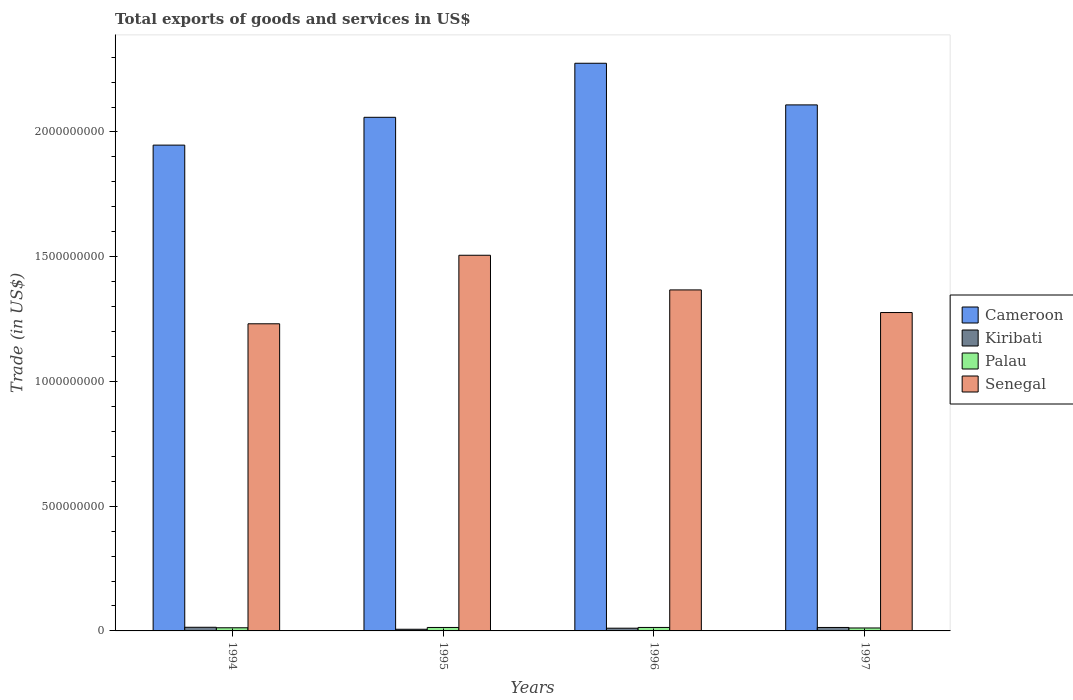How many bars are there on the 2nd tick from the left?
Give a very brief answer. 4. How many bars are there on the 4th tick from the right?
Ensure brevity in your answer.  4. What is the total exports of goods and services in Senegal in 1997?
Provide a short and direct response. 1.28e+09. Across all years, what is the maximum total exports of goods and services in Senegal?
Provide a short and direct response. 1.51e+09. Across all years, what is the minimum total exports of goods and services in Cameroon?
Provide a short and direct response. 1.95e+09. In which year was the total exports of goods and services in Kiribati maximum?
Provide a succinct answer. 1994. What is the total total exports of goods and services in Cameroon in the graph?
Ensure brevity in your answer.  8.39e+09. What is the difference between the total exports of goods and services in Kiribati in 1995 and that in 1996?
Keep it short and to the point. -4.28e+06. What is the difference between the total exports of goods and services in Cameroon in 1997 and the total exports of goods and services in Kiribati in 1995?
Give a very brief answer. 2.10e+09. What is the average total exports of goods and services in Senegal per year?
Offer a terse response. 1.35e+09. In the year 1997, what is the difference between the total exports of goods and services in Senegal and total exports of goods and services in Kiribati?
Ensure brevity in your answer.  1.26e+09. What is the ratio of the total exports of goods and services in Cameroon in 1994 to that in 1996?
Keep it short and to the point. 0.86. What is the difference between the highest and the second highest total exports of goods and services in Kiribati?
Offer a terse response. 7.67e+05. What is the difference between the highest and the lowest total exports of goods and services in Senegal?
Your response must be concise. 2.75e+08. In how many years, is the total exports of goods and services in Senegal greater than the average total exports of goods and services in Senegal taken over all years?
Offer a terse response. 2. What does the 2nd bar from the left in 1995 represents?
Your answer should be very brief. Kiribati. What does the 2nd bar from the right in 1995 represents?
Your response must be concise. Palau. Is it the case that in every year, the sum of the total exports of goods and services in Kiribati and total exports of goods and services in Senegal is greater than the total exports of goods and services in Palau?
Make the answer very short. Yes. How many years are there in the graph?
Provide a short and direct response. 4. What is the difference between two consecutive major ticks on the Y-axis?
Keep it short and to the point. 5.00e+08. Are the values on the major ticks of Y-axis written in scientific E-notation?
Your answer should be very brief. No. Does the graph contain any zero values?
Give a very brief answer. No. Does the graph contain grids?
Your answer should be very brief. No. Where does the legend appear in the graph?
Offer a very short reply. Center right. What is the title of the graph?
Your answer should be very brief. Total exports of goods and services in US$. What is the label or title of the Y-axis?
Offer a very short reply. Trade (in US$). What is the Trade (in US$) of Cameroon in 1994?
Offer a terse response. 1.95e+09. What is the Trade (in US$) of Kiribati in 1994?
Give a very brief answer. 1.46e+07. What is the Trade (in US$) of Palau in 1994?
Your response must be concise. 1.26e+07. What is the Trade (in US$) of Senegal in 1994?
Your answer should be compact. 1.23e+09. What is the Trade (in US$) of Cameroon in 1995?
Ensure brevity in your answer.  2.06e+09. What is the Trade (in US$) of Kiribati in 1995?
Provide a succinct answer. 6.67e+06. What is the Trade (in US$) of Palau in 1995?
Provide a short and direct response. 1.39e+07. What is the Trade (in US$) in Senegal in 1995?
Ensure brevity in your answer.  1.51e+09. What is the Trade (in US$) in Cameroon in 1996?
Offer a terse response. 2.28e+09. What is the Trade (in US$) of Kiribati in 1996?
Offer a very short reply. 1.10e+07. What is the Trade (in US$) of Palau in 1996?
Your answer should be very brief. 1.39e+07. What is the Trade (in US$) of Senegal in 1996?
Your response must be concise. 1.37e+09. What is the Trade (in US$) of Cameroon in 1997?
Offer a terse response. 2.11e+09. What is the Trade (in US$) in Kiribati in 1997?
Offer a very short reply. 1.39e+07. What is the Trade (in US$) in Palau in 1997?
Your answer should be compact. 1.18e+07. What is the Trade (in US$) in Senegal in 1997?
Keep it short and to the point. 1.28e+09. Across all years, what is the maximum Trade (in US$) of Cameroon?
Make the answer very short. 2.28e+09. Across all years, what is the maximum Trade (in US$) in Kiribati?
Your response must be concise. 1.46e+07. Across all years, what is the maximum Trade (in US$) in Palau?
Give a very brief answer. 1.39e+07. Across all years, what is the maximum Trade (in US$) of Senegal?
Your response must be concise. 1.51e+09. Across all years, what is the minimum Trade (in US$) in Cameroon?
Provide a short and direct response. 1.95e+09. Across all years, what is the minimum Trade (in US$) of Kiribati?
Your answer should be very brief. 6.67e+06. Across all years, what is the minimum Trade (in US$) in Palau?
Your response must be concise. 1.18e+07. Across all years, what is the minimum Trade (in US$) of Senegal?
Give a very brief answer. 1.23e+09. What is the total Trade (in US$) in Cameroon in the graph?
Offer a terse response. 8.39e+09. What is the total Trade (in US$) in Kiribati in the graph?
Your answer should be compact. 4.62e+07. What is the total Trade (in US$) of Palau in the graph?
Offer a terse response. 5.22e+07. What is the total Trade (in US$) in Senegal in the graph?
Offer a terse response. 5.38e+09. What is the difference between the Trade (in US$) in Cameroon in 1994 and that in 1995?
Your answer should be very brief. -1.11e+08. What is the difference between the Trade (in US$) of Kiribati in 1994 and that in 1995?
Provide a succinct answer. 7.97e+06. What is the difference between the Trade (in US$) of Palau in 1994 and that in 1995?
Offer a very short reply. -1.27e+06. What is the difference between the Trade (in US$) in Senegal in 1994 and that in 1995?
Your answer should be very brief. -2.75e+08. What is the difference between the Trade (in US$) in Cameroon in 1994 and that in 1996?
Provide a succinct answer. -3.28e+08. What is the difference between the Trade (in US$) in Kiribati in 1994 and that in 1996?
Your answer should be very brief. 3.69e+06. What is the difference between the Trade (in US$) in Palau in 1994 and that in 1996?
Provide a succinct answer. -1.31e+06. What is the difference between the Trade (in US$) in Senegal in 1994 and that in 1996?
Your response must be concise. -1.36e+08. What is the difference between the Trade (in US$) of Cameroon in 1994 and that in 1997?
Ensure brevity in your answer.  -1.61e+08. What is the difference between the Trade (in US$) of Kiribati in 1994 and that in 1997?
Provide a succinct answer. 7.67e+05. What is the difference between the Trade (in US$) of Palau in 1994 and that in 1997?
Offer a terse response. 7.88e+05. What is the difference between the Trade (in US$) in Senegal in 1994 and that in 1997?
Offer a terse response. -4.51e+07. What is the difference between the Trade (in US$) of Cameroon in 1995 and that in 1996?
Make the answer very short. -2.17e+08. What is the difference between the Trade (in US$) of Kiribati in 1995 and that in 1996?
Give a very brief answer. -4.28e+06. What is the difference between the Trade (in US$) of Palau in 1995 and that in 1996?
Your answer should be compact. -3.90e+04. What is the difference between the Trade (in US$) of Senegal in 1995 and that in 1996?
Make the answer very short. 1.39e+08. What is the difference between the Trade (in US$) in Cameroon in 1995 and that in 1997?
Make the answer very short. -4.98e+07. What is the difference between the Trade (in US$) in Kiribati in 1995 and that in 1997?
Your answer should be very brief. -7.21e+06. What is the difference between the Trade (in US$) of Palau in 1995 and that in 1997?
Provide a succinct answer. 2.06e+06. What is the difference between the Trade (in US$) in Senegal in 1995 and that in 1997?
Provide a short and direct response. 2.30e+08. What is the difference between the Trade (in US$) of Cameroon in 1996 and that in 1997?
Offer a very short reply. 1.67e+08. What is the difference between the Trade (in US$) of Kiribati in 1996 and that in 1997?
Keep it short and to the point. -2.92e+06. What is the difference between the Trade (in US$) in Palau in 1996 and that in 1997?
Offer a terse response. 2.10e+06. What is the difference between the Trade (in US$) in Senegal in 1996 and that in 1997?
Provide a short and direct response. 9.07e+07. What is the difference between the Trade (in US$) in Cameroon in 1994 and the Trade (in US$) in Kiribati in 1995?
Ensure brevity in your answer.  1.94e+09. What is the difference between the Trade (in US$) in Cameroon in 1994 and the Trade (in US$) in Palau in 1995?
Your response must be concise. 1.93e+09. What is the difference between the Trade (in US$) in Cameroon in 1994 and the Trade (in US$) in Senegal in 1995?
Your answer should be compact. 4.42e+08. What is the difference between the Trade (in US$) of Kiribati in 1994 and the Trade (in US$) of Palau in 1995?
Provide a succinct answer. 7.78e+05. What is the difference between the Trade (in US$) in Kiribati in 1994 and the Trade (in US$) in Senegal in 1995?
Keep it short and to the point. -1.49e+09. What is the difference between the Trade (in US$) of Palau in 1994 and the Trade (in US$) of Senegal in 1995?
Provide a short and direct response. -1.49e+09. What is the difference between the Trade (in US$) in Cameroon in 1994 and the Trade (in US$) in Kiribati in 1996?
Provide a short and direct response. 1.94e+09. What is the difference between the Trade (in US$) in Cameroon in 1994 and the Trade (in US$) in Palau in 1996?
Offer a very short reply. 1.93e+09. What is the difference between the Trade (in US$) of Cameroon in 1994 and the Trade (in US$) of Senegal in 1996?
Your answer should be compact. 5.80e+08. What is the difference between the Trade (in US$) in Kiribati in 1994 and the Trade (in US$) in Palau in 1996?
Ensure brevity in your answer.  7.39e+05. What is the difference between the Trade (in US$) in Kiribati in 1994 and the Trade (in US$) in Senegal in 1996?
Your answer should be very brief. -1.35e+09. What is the difference between the Trade (in US$) of Palau in 1994 and the Trade (in US$) of Senegal in 1996?
Offer a very short reply. -1.35e+09. What is the difference between the Trade (in US$) in Cameroon in 1994 and the Trade (in US$) in Kiribati in 1997?
Give a very brief answer. 1.93e+09. What is the difference between the Trade (in US$) in Cameroon in 1994 and the Trade (in US$) in Palau in 1997?
Your answer should be very brief. 1.94e+09. What is the difference between the Trade (in US$) of Cameroon in 1994 and the Trade (in US$) of Senegal in 1997?
Ensure brevity in your answer.  6.71e+08. What is the difference between the Trade (in US$) of Kiribati in 1994 and the Trade (in US$) of Palau in 1997?
Provide a succinct answer. 2.83e+06. What is the difference between the Trade (in US$) in Kiribati in 1994 and the Trade (in US$) in Senegal in 1997?
Your answer should be compact. -1.26e+09. What is the difference between the Trade (in US$) of Palau in 1994 and the Trade (in US$) of Senegal in 1997?
Provide a short and direct response. -1.26e+09. What is the difference between the Trade (in US$) in Cameroon in 1995 and the Trade (in US$) in Kiribati in 1996?
Give a very brief answer. 2.05e+09. What is the difference between the Trade (in US$) in Cameroon in 1995 and the Trade (in US$) in Palau in 1996?
Your answer should be very brief. 2.04e+09. What is the difference between the Trade (in US$) of Cameroon in 1995 and the Trade (in US$) of Senegal in 1996?
Provide a succinct answer. 6.92e+08. What is the difference between the Trade (in US$) in Kiribati in 1995 and the Trade (in US$) in Palau in 1996?
Offer a terse response. -7.24e+06. What is the difference between the Trade (in US$) of Kiribati in 1995 and the Trade (in US$) of Senegal in 1996?
Provide a succinct answer. -1.36e+09. What is the difference between the Trade (in US$) of Palau in 1995 and the Trade (in US$) of Senegal in 1996?
Your answer should be compact. -1.35e+09. What is the difference between the Trade (in US$) of Cameroon in 1995 and the Trade (in US$) of Kiribati in 1997?
Your answer should be very brief. 2.05e+09. What is the difference between the Trade (in US$) in Cameroon in 1995 and the Trade (in US$) in Palau in 1997?
Ensure brevity in your answer.  2.05e+09. What is the difference between the Trade (in US$) of Cameroon in 1995 and the Trade (in US$) of Senegal in 1997?
Offer a very short reply. 7.83e+08. What is the difference between the Trade (in US$) of Kiribati in 1995 and the Trade (in US$) of Palau in 1997?
Make the answer very short. -5.14e+06. What is the difference between the Trade (in US$) of Kiribati in 1995 and the Trade (in US$) of Senegal in 1997?
Your response must be concise. -1.27e+09. What is the difference between the Trade (in US$) of Palau in 1995 and the Trade (in US$) of Senegal in 1997?
Make the answer very short. -1.26e+09. What is the difference between the Trade (in US$) in Cameroon in 1996 and the Trade (in US$) in Kiribati in 1997?
Make the answer very short. 2.26e+09. What is the difference between the Trade (in US$) of Cameroon in 1996 and the Trade (in US$) of Palau in 1997?
Keep it short and to the point. 2.26e+09. What is the difference between the Trade (in US$) in Cameroon in 1996 and the Trade (in US$) in Senegal in 1997?
Give a very brief answer. 9.99e+08. What is the difference between the Trade (in US$) in Kiribati in 1996 and the Trade (in US$) in Palau in 1997?
Ensure brevity in your answer.  -8.57e+05. What is the difference between the Trade (in US$) in Kiribati in 1996 and the Trade (in US$) in Senegal in 1997?
Offer a terse response. -1.27e+09. What is the difference between the Trade (in US$) of Palau in 1996 and the Trade (in US$) of Senegal in 1997?
Make the answer very short. -1.26e+09. What is the average Trade (in US$) of Cameroon per year?
Offer a very short reply. 2.10e+09. What is the average Trade (in US$) in Kiribati per year?
Offer a terse response. 1.15e+07. What is the average Trade (in US$) of Palau per year?
Offer a terse response. 1.30e+07. What is the average Trade (in US$) in Senegal per year?
Your response must be concise. 1.35e+09. In the year 1994, what is the difference between the Trade (in US$) of Cameroon and Trade (in US$) of Kiribati?
Your answer should be very brief. 1.93e+09. In the year 1994, what is the difference between the Trade (in US$) of Cameroon and Trade (in US$) of Palau?
Make the answer very short. 1.93e+09. In the year 1994, what is the difference between the Trade (in US$) of Cameroon and Trade (in US$) of Senegal?
Ensure brevity in your answer.  7.16e+08. In the year 1994, what is the difference between the Trade (in US$) of Kiribati and Trade (in US$) of Palau?
Ensure brevity in your answer.  2.05e+06. In the year 1994, what is the difference between the Trade (in US$) in Kiribati and Trade (in US$) in Senegal?
Your answer should be very brief. -1.22e+09. In the year 1994, what is the difference between the Trade (in US$) in Palau and Trade (in US$) in Senegal?
Offer a terse response. -1.22e+09. In the year 1995, what is the difference between the Trade (in US$) in Cameroon and Trade (in US$) in Kiribati?
Ensure brevity in your answer.  2.05e+09. In the year 1995, what is the difference between the Trade (in US$) in Cameroon and Trade (in US$) in Palau?
Offer a very short reply. 2.05e+09. In the year 1995, what is the difference between the Trade (in US$) in Cameroon and Trade (in US$) in Senegal?
Ensure brevity in your answer.  5.53e+08. In the year 1995, what is the difference between the Trade (in US$) in Kiribati and Trade (in US$) in Palau?
Offer a very short reply. -7.20e+06. In the year 1995, what is the difference between the Trade (in US$) of Kiribati and Trade (in US$) of Senegal?
Ensure brevity in your answer.  -1.50e+09. In the year 1995, what is the difference between the Trade (in US$) of Palau and Trade (in US$) of Senegal?
Provide a succinct answer. -1.49e+09. In the year 1996, what is the difference between the Trade (in US$) of Cameroon and Trade (in US$) of Kiribati?
Provide a succinct answer. 2.26e+09. In the year 1996, what is the difference between the Trade (in US$) of Cameroon and Trade (in US$) of Palau?
Your answer should be compact. 2.26e+09. In the year 1996, what is the difference between the Trade (in US$) of Cameroon and Trade (in US$) of Senegal?
Give a very brief answer. 9.09e+08. In the year 1996, what is the difference between the Trade (in US$) of Kiribati and Trade (in US$) of Palau?
Your answer should be very brief. -2.95e+06. In the year 1996, what is the difference between the Trade (in US$) of Kiribati and Trade (in US$) of Senegal?
Offer a terse response. -1.36e+09. In the year 1996, what is the difference between the Trade (in US$) in Palau and Trade (in US$) in Senegal?
Your answer should be compact. -1.35e+09. In the year 1997, what is the difference between the Trade (in US$) of Cameroon and Trade (in US$) of Kiribati?
Make the answer very short. 2.09e+09. In the year 1997, what is the difference between the Trade (in US$) in Cameroon and Trade (in US$) in Palau?
Offer a very short reply. 2.10e+09. In the year 1997, what is the difference between the Trade (in US$) of Cameroon and Trade (in US$) of Senegal?
Your answer should be compact. 8.32e+08. In the year 1997, what is the difference between the Trade (in US$) of Kiribati and Trade (in US$) of Palau?
Give a very brief answer. 2.07e+06. In the year 1997, what is the difference between the Trade (in US$) in Kiribati and Trade (in US$) in Senegal?
Your answer should be very brief. -1.26e+09. In the year 1997, what is the difference between the Trade (in US$) in Palau and Trade (in US$) in Senegal?
Your answer should be very brief. -1.26e+09. What is the ratio of the Trade (in US$) of Cameroon in 1994 to that in 1995?
Provide a short and direct response. 0.95. What is the ratio of the Trade (in US$) in Kiribati in 1994 to that in 1995?
Offer a very short reply. 2.2. What is the ratio of the Trade (in US$) in Palau in 1994 to that in 1995?
Provide a short and direct response. 0.91. What is the ratio of the Trade (in US$) in Senegal in 1994 to that in 1995?
Give a very brief answer. 0.82. What is the ratio of the Trade (in US$) of Cameroon in 1994 to that in 1996?
Give a very brief answer. 0.86. What is the ratio of the Trade (in US$) in Kiribati in 1994 to that in 1996?
Your answer should be compact. 1.34. What is the ratio of the Trade (in US$) of Palau in 1994 to that in 1996?
Offer a terse response. 0.91. What is the ratio of the Trade (in US$) in Senegal in 1994 to that in 1996?
Offer a very short reply. 0.9. What is the ratio of the Trade (in US$) in Cameroon in 1994 to that in 1997?
Keep it short and to the point. 0.92. What is the ratio of the Trade (in US$) of Kiribati in 1994 to that in 1997?
Provide a short and direct response. 1.06. What is the ratio of the Trade (in US$) of Palau in 1994 to that in 1997?
Make the answer very short. 1.07. What is the ratio of the Trade (in US$) of Senegal in 1994 to that in 1997?
Offer a very short reply. 0.96. What is the ratio of the Trade (in US$) in Cameroon in 1995 to that in 1996?
Give a very brief answer. 0.9. What is the ratio of the Trade (in US$) of Kiribati in 1995 to that in 1996?
Give a very brief answer. 0.61. What is the ratio of the Trade (in US$) in Senegal in 1995 to that in 1996?
Give a very brief answer. 1.1. What is the ratio of the Trade (in US$) in Cameroon in 1995 to that in 1997?
Your answer should be very brief. 0.98. What is the ratio of the Trade (in US$) in Kiribati in 1995 to that in 1997?
Your response must be concise. 0.48. What is the ratio of the Trade (in US$) in Palau in 1995 to that in 1997?
Your response must be concise. 1.17. What is the ratio of the Trade (in US$) of Senegal in 1995 to that in 1997?
Provide a short and direct response. 1.18. What is the ratio of the Trade (in US$) in Cameroon in 1996 to that in 1997?
Provide a succinct answer. 1.08. What is the ratio of the Trade (in US$) of Kiribati in 1996 to that in 1997?
Make the answer very short. 0.79. What is the ratio of the Trade (in US$) in Palau in 1996 to that in 1997?
Ensure brevity in your answer.  1.18. What is the ratio of the Trade (in US$) of Senegal in 1996 to that in 1997?
Provide a succinct answer. 1.07. What is the difference between the highest and the second highest Trade (in US$) of Cameroon?
Your response must be concise. 1.67e+08. What is the difference between the highest and the second highest Trade (in US$) in Kiribati?
Offer a terse response. 7.67e+05. What is the difference between the highest and the second highest Trade (in US$) in Palau?
Make the answer very short. 3.90e+04. What is the difference between the highest and the second highest Trade (in US$) in Senegal?
Your response must be concise. 1.39e+08. What is the difference between the highest and the lowest Trade (in US$) of Cameroon?
Your response must be concise. 3.28e+08. What is the difference between the highest and the lowest Trade (in US$) of Kiribati?
Your answer should be compact. 7.97e+06. What is the difference between the highest and the lowest Trade (in US$) of Palau?
Offer a very short reply. 2.10e+06. What is the difference between the highest and the lowest Trade (in US$) in Senegal?
Ensure brevity in your answer.  2.75e+08. 